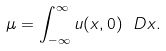<formula> <loc_0><loc_0><loc_500><loc_500>\mu = \int _ { - \infty } ^ { \infty } u ( x , 0 ) \ D x .</formula> 